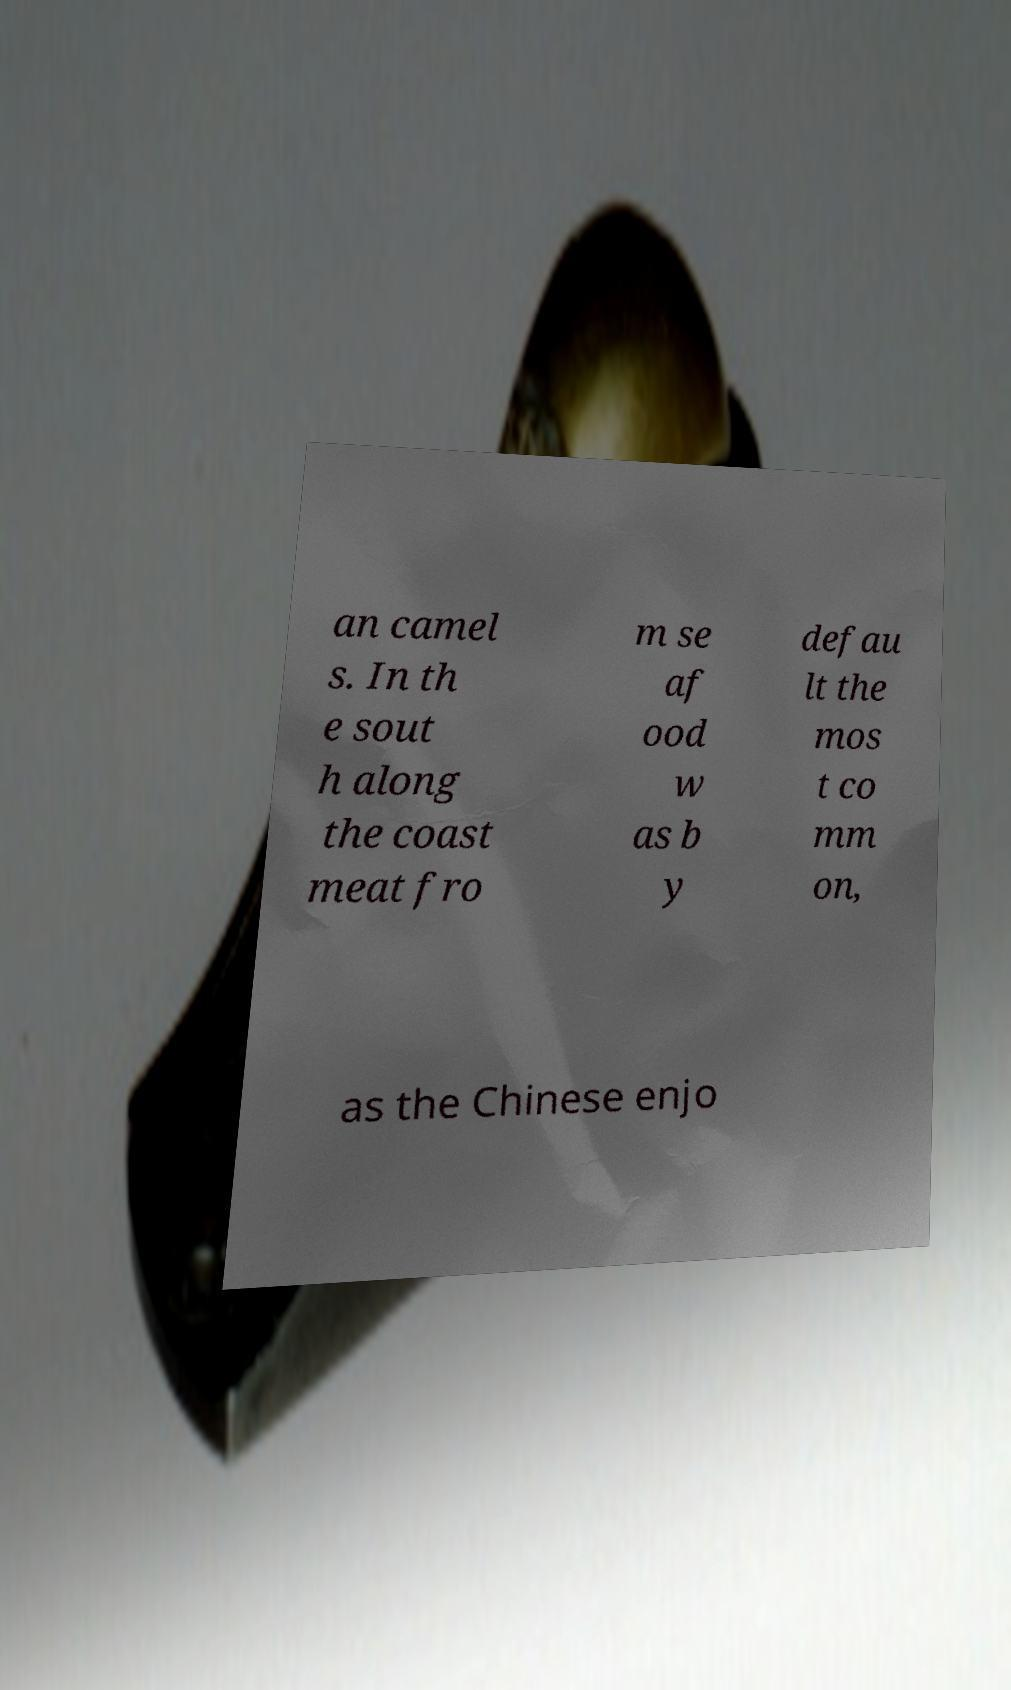Please identify and transcribe the text found in this image. an camel s. In th e sout h along the coast meat fro m se af ood w as b y defau lt the mos t co mm on, as the Chinese enjo 